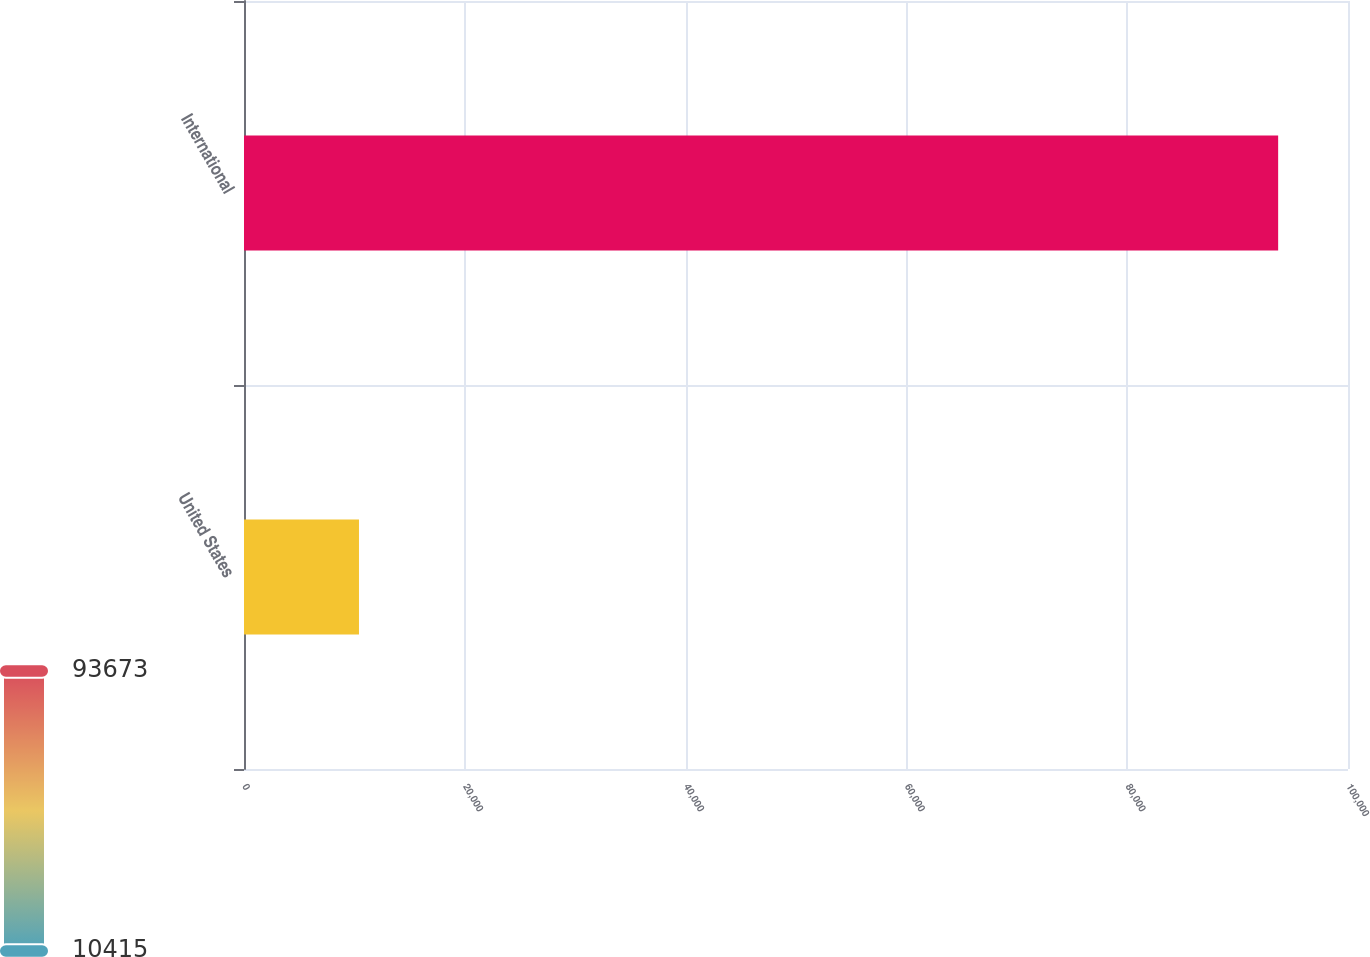Convert chart. <chart><loc_0><loc_0><loc_500><loc_500><bar_chart><fcel>United States<fcel>International<nl><fcel>10415<fcel>93673<nl></chart> 